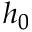<formula> <loc_0><loc_0><loc_500><loc_500>h _ { 0 }</formula> 